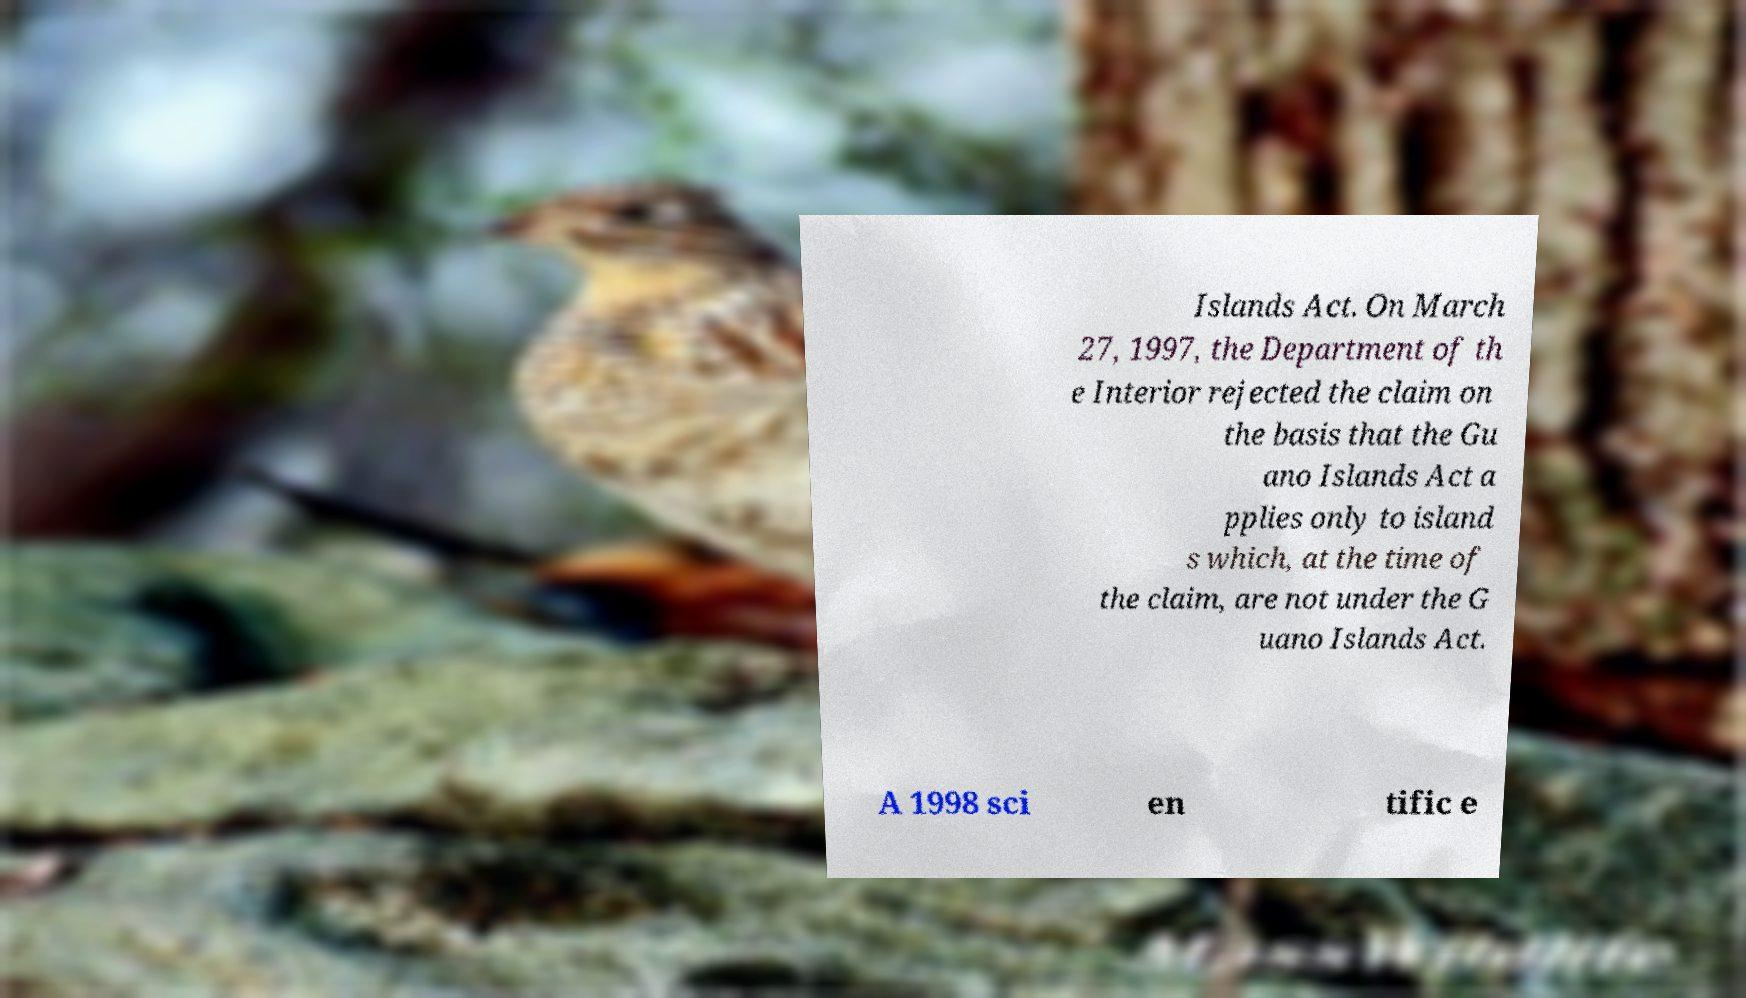I need the written content from this picture converted into text. Can you do that? Islands Act. On March 27, 1997, the Department of th e Interior rejected the claim on the basis that the Gu ano Islands Act a pplies only to island s which, at the time of the claim, are not under the G uano Islands Act. A 1998 sci en tific e 